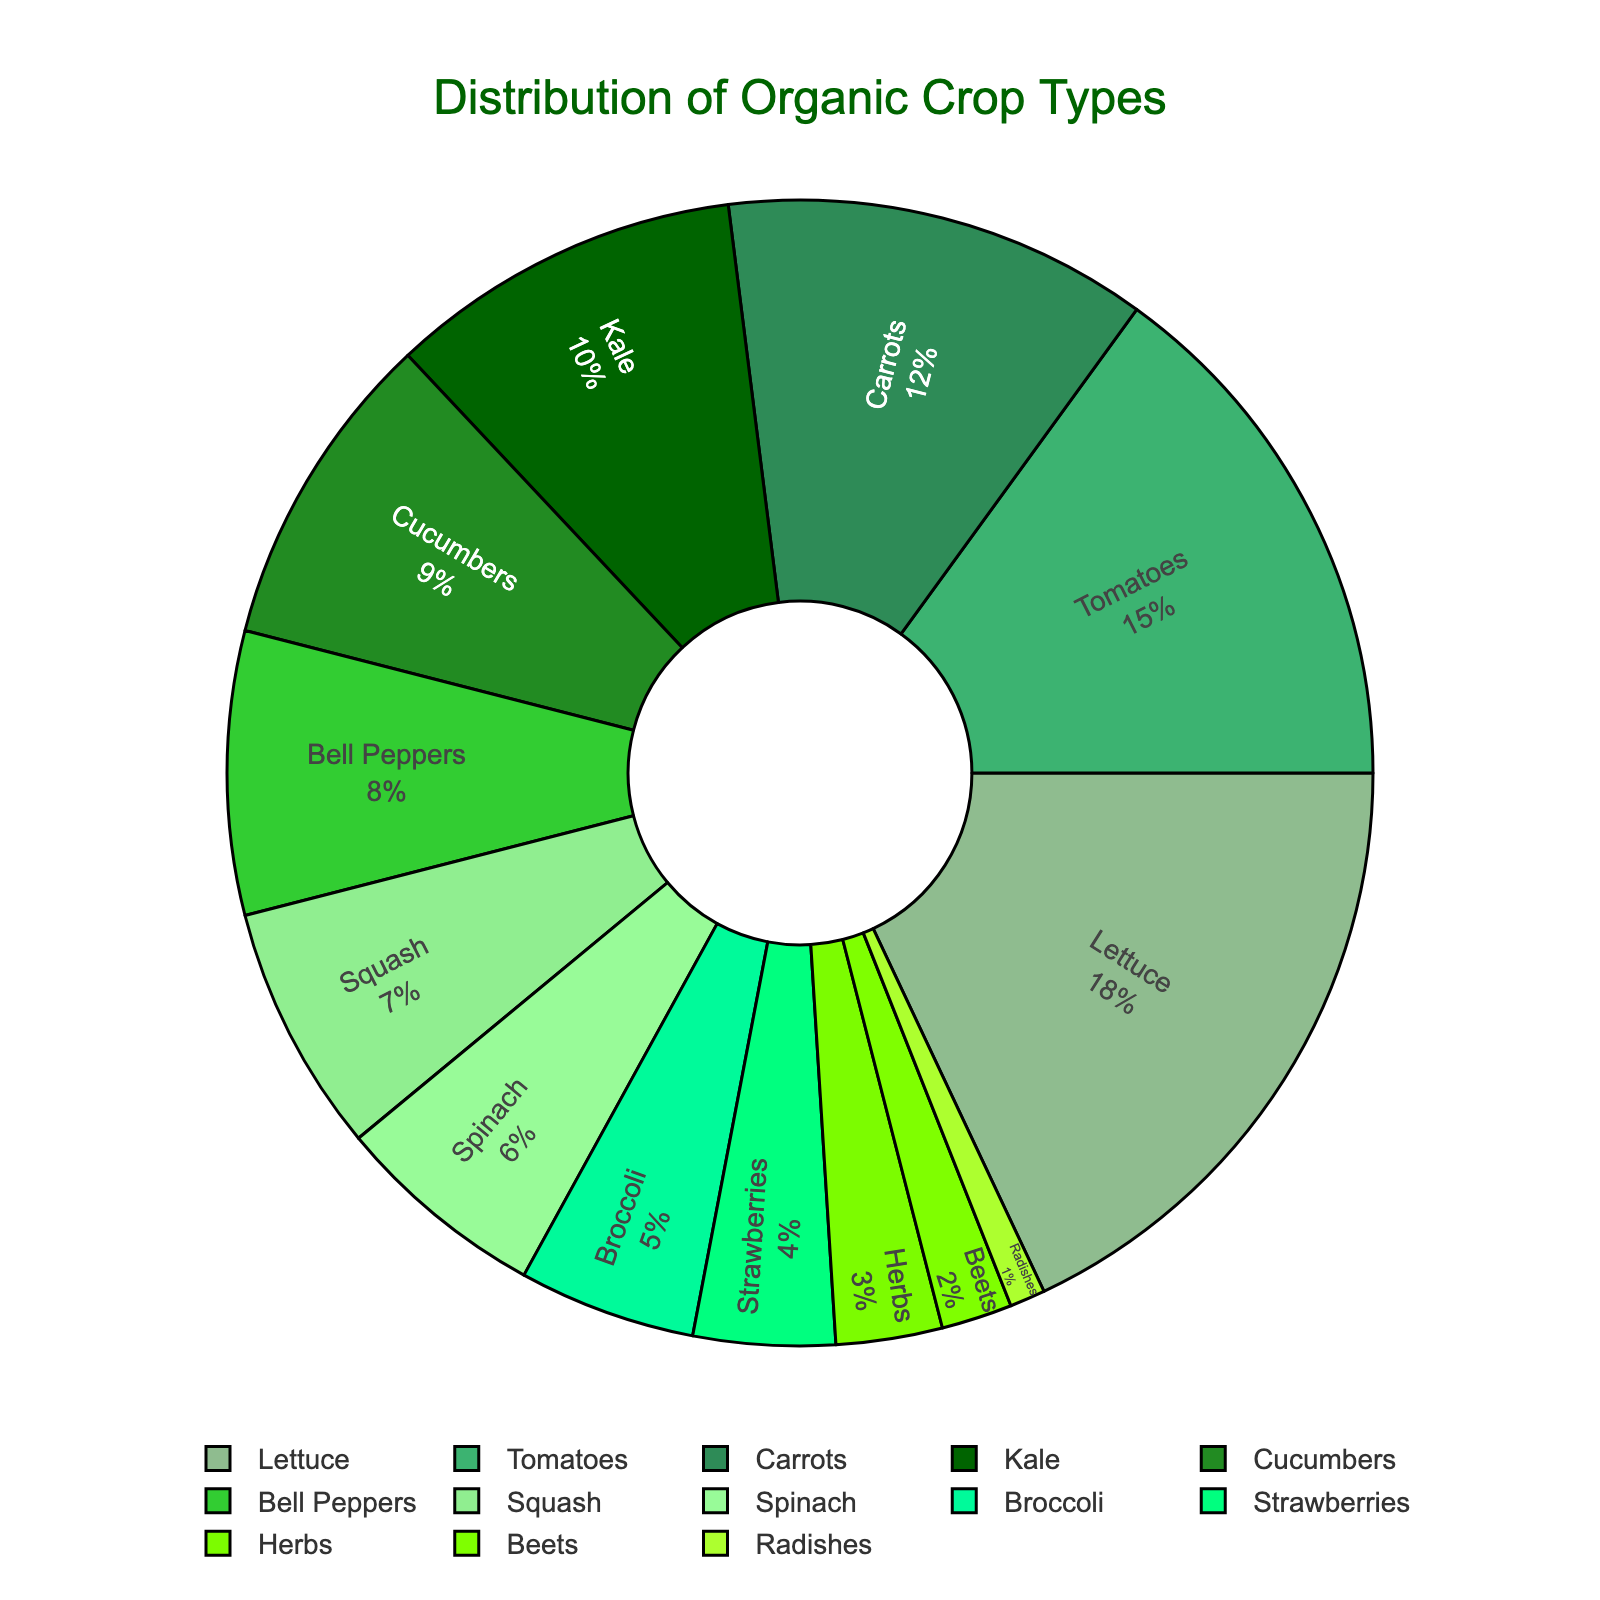What is the most grown crop on the farm? By looking at the pie chart, identify the segment with the largest percentage. The label "Lettuce" occupies the largest portion of the pie.
Answer: Lettuce Which two crops have the smallest share in the distribution? By looking at the pie chart, identify the two smallest segments. The labels correspond to "Radishes" and "Beets," which have the smallest sections.
Answer: Radishes and Beets How much larger is the percentage of Tomatoes compared to Cucumbers? Identify the percentages of both crops from the pie chart and subtract the smaller from the larger. Tomatoes are 15% and Cucumbers are 9%. So, 15 - 9 = 6.
Answer: 6% If you combine the percentages of Kale, Bell Peppers, and Broccoli, what is their total percentage? Identify the percentages of Kale (10%), Bell Peppers (8%), and Broccoli (5%) and add them together. 10 + 8 + 5 = 23.
Answer: 23% Which is grown more, Kale or Spinach? By how much? Identify the percentages from the pie chart. Kale is 10% and Spinach is 6%. Subtract the smaller percentage from the larger. 10 - 6 = 4.
Answer: Kale, by 4% What is the combined percentage of all leafy greens (Lettuce, Kale, Spinach)? Identify the percentages and sum them up. Lettuce (18%), Kale (10%), Spinach (6%). 18 + 10 + 6 = 34.
Answer: 34% What is the percentage difference between Carrots and Bell Peppers? Identify the percentages from the pie chart. Carrots are 12% and Bell Peppers are 8%. Subtract the smaller percentage from the larger. 12 - 8 = 4.
Answer: 4% Which segment is green in color and represents the third largest crop category? By visually analyzing the pie chart, identify the green segment corresponding to the third-largest percentage. The green section representing Carrots is the third largest at 12%.
Answer: Carrots Out of the total crops, what percentage does non-leafy vegetables (Tomatoes, Carrots, Cucumbers, Bell Peppers, Squash, Broccoli, Beets, Radishes) represent? Sum the percentages of non-leafy vegetables. 15 (Tomatoes) + 12 (Carrots) + 9 (Cucumbers) + 8 (Bell Peppers) + 7 (Squash) + 5 (Broccoli) + 2 (Beets) + 1 (Radishes) = 59%.
Answer: 59% What percentage of the total crop distribution do fruit-bearing plants (Tomatoes, Bell Peppers, Strawberries) make up? Sum the percentages of these crops from the pie chart: Tomatoes (15%), Bell Peppers (8%), Strawberries (4%). 15 + 8 + 4 = 27.
Answer: 27% 